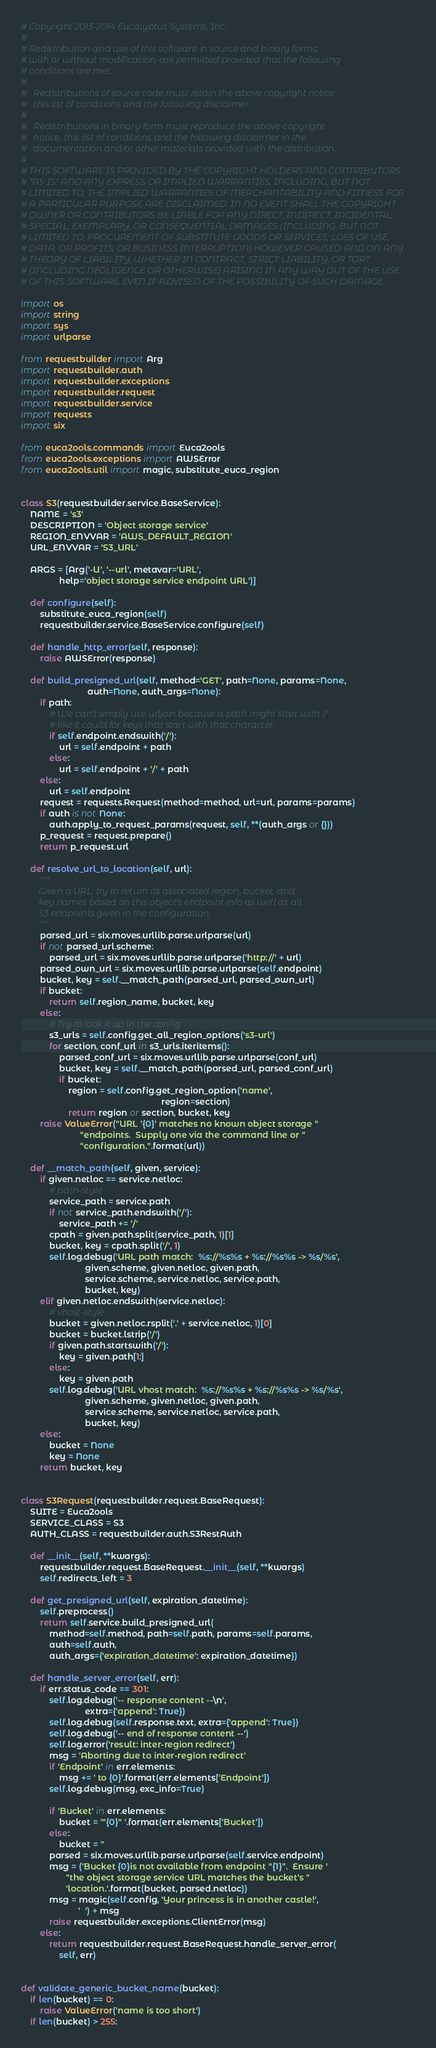Convert code to text. <code><loc_0><loc_0><loc_500><loc_500><_Python_># Copyright 2013-2014 Eucalyptus Systems, Inc.
#
# Redistribution and use of this software in source and binary forms,
# with or without modification, are permitted provided that the following
# conditions are met:
#
#   Redistributions of source code must retain the above copyright notice,
#   this list of conditions and the following disclaimer.
#
#   Redistributions in binary form must reproduce the above copyright
#   notice, this list of conditions and the following disclaimer in the
#   documentation and/or other materials provided with the distribution.
#
# THIS SOFTWARE IS PROVIDED BY THE COPYRIGHT HOLDERS AND CONTRIBUTORS
# "AS IS" AND ANY EXPRESS OR IMPLIED WARRANTIES, INCLUDING, BUT NOT
# LIMITED TO, THE IMPLIED WARRANTIES OF MERCHANTABILITY AND FITNESS FOR
# A PARTICULAR PURPOSE ARE DISCLAIMED. IN NO EVENT SHALL THE COPYRIGHT
# OWNER OR CONTRIBUTORS BE LIABLE FOR ANY DIRECT, INDIRECT, INCIDENTAL,
# SPECIAL, EXEMPLARY, OR CONSEQUENTIAL DAMAGES (INCLUDING, BUT NOT
# LIMITED TO, PROCUREMENT OF SUBSTITUTE GOODS OR SERVICES; LOSS OF USE,
# DATA, OR PROFITS; OR BUSINESS INTERRUPTION) HOWEVER CAUSED AND ON ANY
# THEORY OF LIABILITY, WHETHER IN CONTRACT, STRICT LIABILITY, OR TORT
# (INCLUDING NEGLIGENCE OR OTHERWISE) ARISING IN ANY WAY OUT OF THE USE
# OF THIS SOFTWARE, EVEN IF ADVISED OF THE POSSIBILITY OF SUCH DAMAGE.

import os
import string
import sys
import urlparse

from requestbuilder import Arg
import requestbuilder.auth
import requestbuilder.exceptions
import requestbuilder.request
import requestbuilder.service
import requests
import six

from euca2ools.commands import Euca2ools
from euca2ools.exceptions import AWSError
from euca2ools.util import magic, substitute_euca_region


class S3(requestbuilder.service.BaseService):
    NAME = 's3'
    DESCRIPTION = 'Object storage service'
    REGION_ENVVAR = 'AWS_DEFAULT_REGION'
    URL_ENVVAR = 'S3_URL'

    ARGS = [Arg('-U', '--url', metavar='URL',
                help='object storage service endpoint URL')]

    def configure(self):
        substitute_euca_region(self)
        requestbuilder.service.BaseService.configure(self)

    def handle_http_error(self, response):
        raise AWSError(response)

    def build_presigned_url(self, method='GET', path=None, params=None,
                            auth=None, auth_args=None):
        if path:
            # We can't simply use urljoin because a path might start with '/'
            # like it could for keys that start with that character.
            if self.endpoint.endswith('/'):
                url = self.endpoint + path
            else:
                url = self.endpoint + '/' + path
        else:
            url = self.endpoint
        request = requests.Request(method=method, url=url, params=params)
        if auth is not None:
            auth.apply_to_request_params(request, self, **(auth_args or {}))
        p_request = request.prepare()
        return p_request.url

    def resolve_url_to_location(self, url):
        """
        Given a URL, try to return its associated region, bucket, and
        key names based on this object's endpoint info as well as all
        S3 endpoints given in the configuration.
        """
        parsed_url = six.moves.urllib.parse.urlparse(url)
        if not parsed_url.scheme:
            parsed_url = six.moves.urllib.parse.urlparse('http://' + url)
        parsed_own_url = six.moves.urllib.parse.urlparse(self.endpoint)
        bucket, key = self.__match_path(parsed_url, parsed_own_url)
        if bucket:
            return self.region_name, bucket, key
        else:
            # Try to look it up in the config
            s3_urls = self.config.get_all_region_options('s3-url')
            for section, conf_url in s3_urls.iteritems():
                parsed_conf_url = six.moves.urllib.parse.urlparse(conf_url)
                bucket, key = self.__match_path(parsed_url, parsed_conf_url)
                if bucket:
                    region = self.config.get_region_option('name',
                                                           region=section)
                    return region or section, bucket, key
        raise ValueError("URL '{0}' matches no known object storage "
                         "endpoints.  Supply one via the command line or "
                         "configuration.".format(url))

    def __match_path(self, given, service):
        if given.netloc == service.netloc:
            # path-style
            service_path = service.path
            if not service_path.endswith('/'):
                service_path += '/'
            cpath = given.path.split(service_path, 1)[1]
            bucket, key = cpath.split('/', 1)
            self.log.debug('URL path match:  %s://%s%s + %s://%s%s -> %s/%s',
                           given.scheme, given.netloc, given.path,
                           service.scheme, service.netloc, service.path,
                           bucket, key)
        elif given.netloc.endswith(service.netloc):
            # vhost-style
            bucket = given.netloc.rsplit('.' + service.netloc, 1)[0]
            bucket = bucket.lstrip('/')
            if given.path.startswith('/'):
                key = given.path[1:]
            else:
                key = given.path
            self.log.debug('URL vhost match:  %s://%s%s + %s://%s%s -> %s/%s',
                           given.scheme, given.netloc, given.path,
                           service.scheme, service.netloc, service.path,
                           bucket, key)
        else:
            bucket = None
            key = None
        return bucket, key


class S3Request(requestbuilder.request.BaseRequest):
    SUITE = Euca2ools
    SERVICE_CLASS = S3
    AUTH_CLASS = requestbuilder.auth.S3RestAuth

    def __init__(self, **kwargs):
        requestbuilder.request.BaseRequest.__init__(self, **kwargs)
        self.redirects_left = 3

    def get_presigned_url(self, expiration_datetime):
        self.preprocess()
        return self.service.build_presigned_url(
            method=self.method, path=self.path, params=self.params,
            auth=self.auth,
            auth_args={'expiration_datetime': expiration_datetime})

    def handle_server_error(self, err):
        if err.status_code == 301:
            self.log.debug('-- response content --\n',
                           extra={'append': True})
            self.log.debug(self.response.text, extra={'append': True})
            self.log.debug('-- end of response content --')
            self.log.error('result: inter-region redirect')
            msg = 'Aborting due to inter-region redirect'
            if 'Endpoint' in err.elements:
                msg += ' to {0}'.format(err.elements['Endpoint'])
            self.log.debug(msg, exc_info=True)

            if 'Bucket' in err.elements:
                bucket = '"{0}" '.format(err.elements['Bucket'])
            else:
                bucket = ''
            parsed = six.moves.urllib.parse.urlparse(self.service.endpoint)
            msg = ('Bucket {0}is not available from endpoint "{1}".  Ensure '
                   "the object storage service URL matches the bucket's "
                   'location.'.format(bucket, parsed.netloc))
            msg = magic(self.config, 'Your princess is in another castle!',
                        '  ') + msg
            raise requestbuilder.exceptions.ClientError(msg)
        else:
            return requestbuilder.request.BaseRequest.handle_server_error(
                self, err)


def validate_generic_bucket_name(bucket):
    if len(bucket) == 0:
        raise ValueError('name is too short')
    if len(bucket) > 255:</code> 